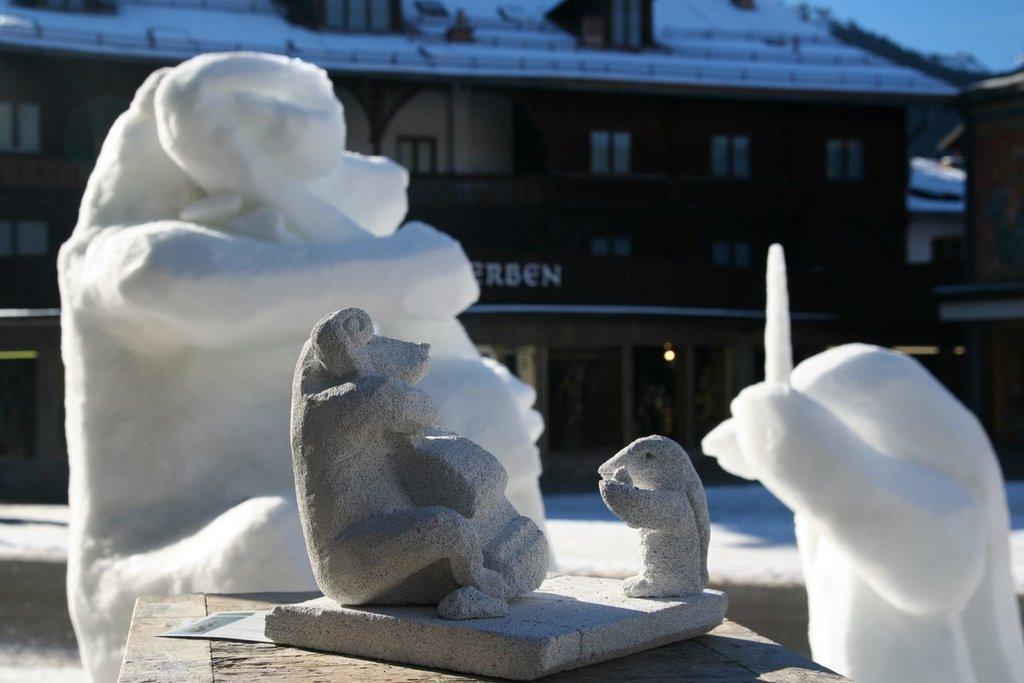In one or two sentences, can you explain what this image depicts? In the foreground of this image, there is a stone sculpture on a wooden object. Behind it, there are snow sculptures. In the background, there is a building and the sky at the top. 